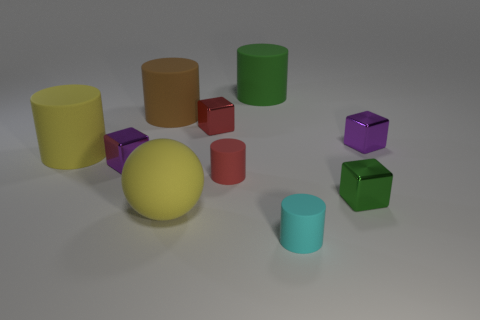What is the material of the green cylinder?
Ensure brevity in your answer.  Rubber. Does the yellow matte ball have the same size as the green matte cylinder?
Make the answer very short. Yes. How many spheres are either cyan rubber objects or big green matte objects?
Give a very brief answer. 0. There is a large thing in front of the small purple block left of the big brown rubber cylinder; what color is it?
Offer a very short reply. Yellow. Are there fewer small red shiny objects to the left of the green metal block than big matte objects that are right of the big brown matte thing?
Ensure brevity in your answer.  Yes. There is a sphere; is it the same size as the yellow matte object on the left side of the yellow rubber ball?
Provide a succinct answer. Yes. There is a big thing that is both in front of the red block and behind the green metallic object; what shape is it?
Your answer should be compact. Cylinder. What is the size of the yellow ball that is made of the same material as the big green cylinder?
Your answer should be very brief. Large. There is a tiny purple cube to the left of the big brown thing; how many things are behind it?
Your answer should be very brief. 5. Are the purple thing to the right of the tiny red metallic object and the large green cylinder made of the same material?
Offer a terse response. No. 